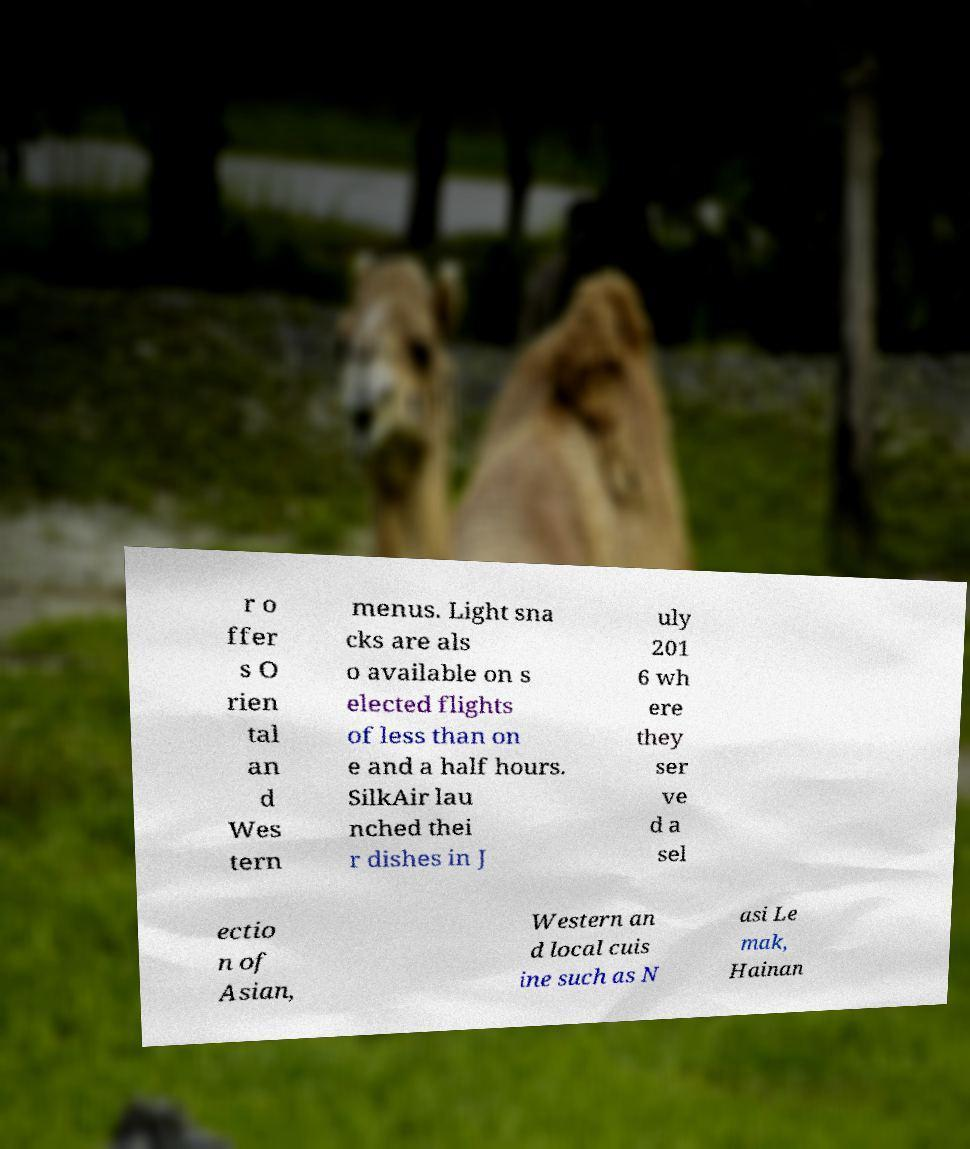Please read and relay the text visible in this image. What does it say? r o ffer s O rien tal an d Wes tern menus. Light sna cks are als o available on s elected flights of less than on e and a half hours. SilkAir lau nched thei r dishes in J uly 201 6 wh ere they ser ve d a sel ectio n of Asian, Western an d local cuis ine such as N asi Le mak, Hainan 